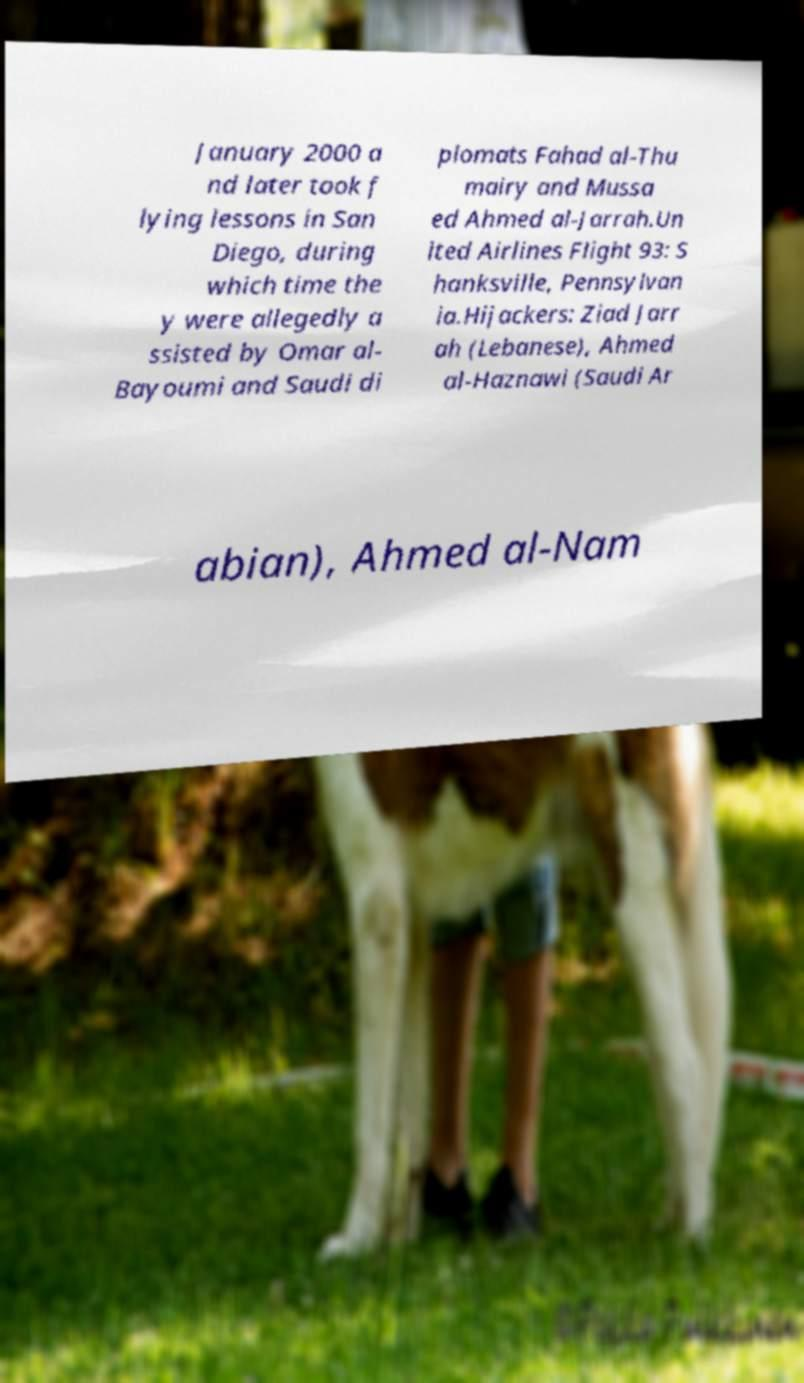Can you read and provide the text displayed in the image?This photo seems to have some interesting text. Can you extract and type it out for me? January 2000 a nd later took f lying lessons in San Diego, during which time the y were allegedly a ssisted by Omar al- Bayoumi and Saudi di plomats Fahad al-Thu mairy and Mussa ed Ahmed al-Jarrah.Un ited Airlines Flight 93: S hanksville, Pennsylvan ia.Hijackers: Ziad Jarr ah (Lebanese), Ahmed al-Haznawi (Saudi Ar abian), Ahmed al-Nam 